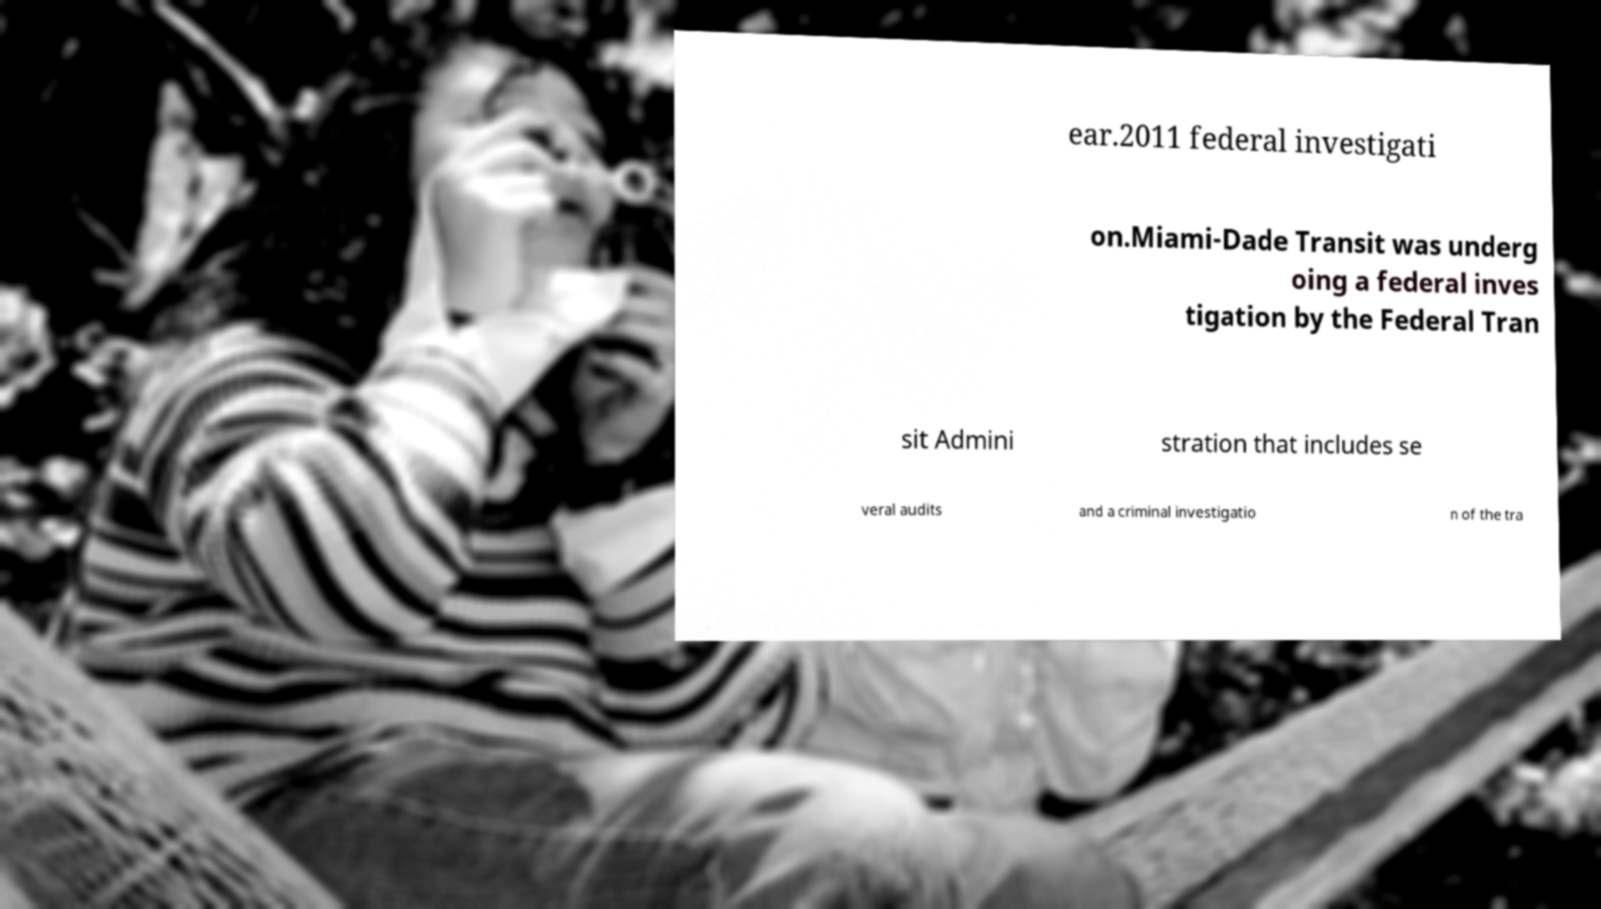Could you assist in decoding the text presented in this image and type it out clearly? ear.2011 federal investigati on.Miami-Dade Transit was underg oing a federal inves tigation by the Federal Tran sit Admini stration that includes se veral audits and a criminal investigatio n of the tra 